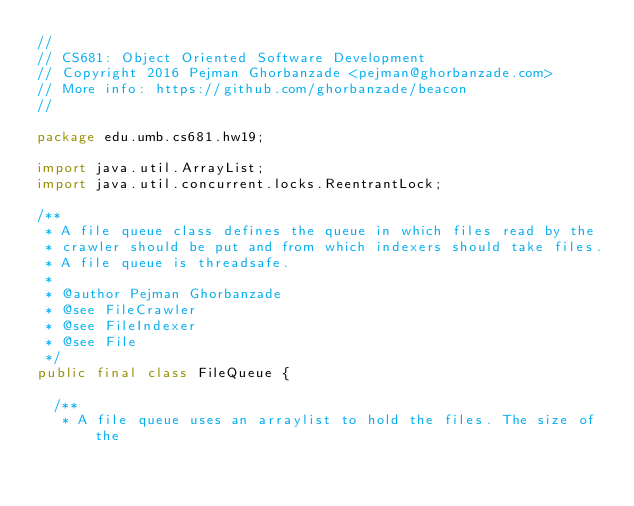<code> <loc_0><loc_0><loc_500><loc_500><_Java_>//
// CS681: Object Oriented Software Development
// Copyright 2016 Pejman Ghorbanzade <pejman@ghorbanzade.com>
// More info: https://github.com/ghorbanzade/beacon
//

package edu.umb.cs681.hw19;

import java.util.ArrayList;
import java.util.concurrent.locks.ReentrantLock;

/**
 * A file queue class defines the queue in which files read by the
 * crawler should be put and from which indexers should take files.
 * A file queue is threadsafe.
 *
 * @author Pejman Ghorbanzade
 * @see FileCrawler
 * @see FileIndexer
 * @see File
 */
public final class FileQueue {

  /**
   * A file queue uses an arraylist to hold the files. The size of the</code> 